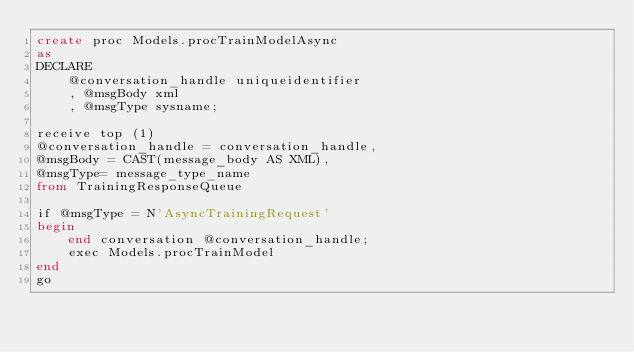<code> <loc_0><loc_0><loc_500><loc_500><_SQL_>create proc Models.procTrainModelAsync
as
DECLARE 
    @conversation_handle uniqueidentifier
    , @msgBody xml
    , @msgType sysname;
 
receive top (1)
@conversation_handle = conversation_handle,
@msgBody = CAST(message_body AS XML),
@msgType= message_type_name
from TrainingResponseQueue
 
if @msgType = N'AsyncTrainingRequest'
begin
    end conversation @conversation_handle;
    exec Models.procTrainModel
end
go</code> 